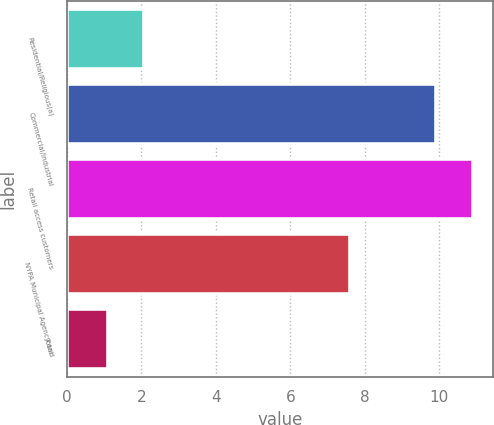Convert chart. <chart><loc_0><loc_0><loc_500><loc_500><bar_chart><fcel>Residential/Religious(a)<fcel>Commercial/Industrial<fcel>Retail access customers<fcel>NYPA Municipal Agency and<fcel>Total<nl><fcel>2.08<fcel>9.9<fcel>10.9<fcel>7.6<fcel>1.1<nl></chart> 